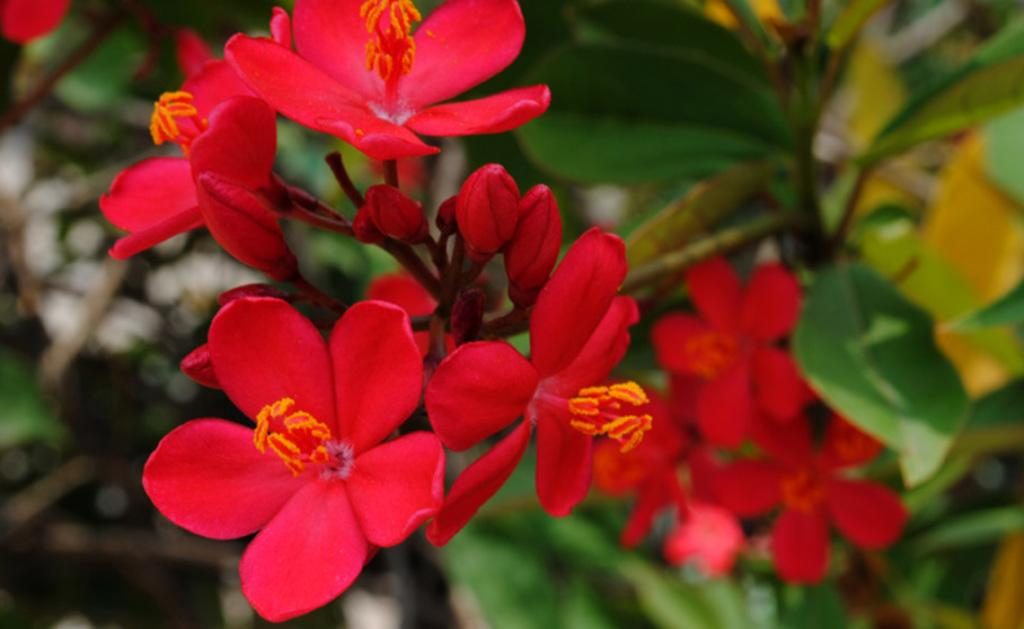What type of flowers can be seen in the image? There are red color flowers in the image. What type of meat is being stored in the crate in the image? There is no crate or meat present in the image; it only features red color flowers. 